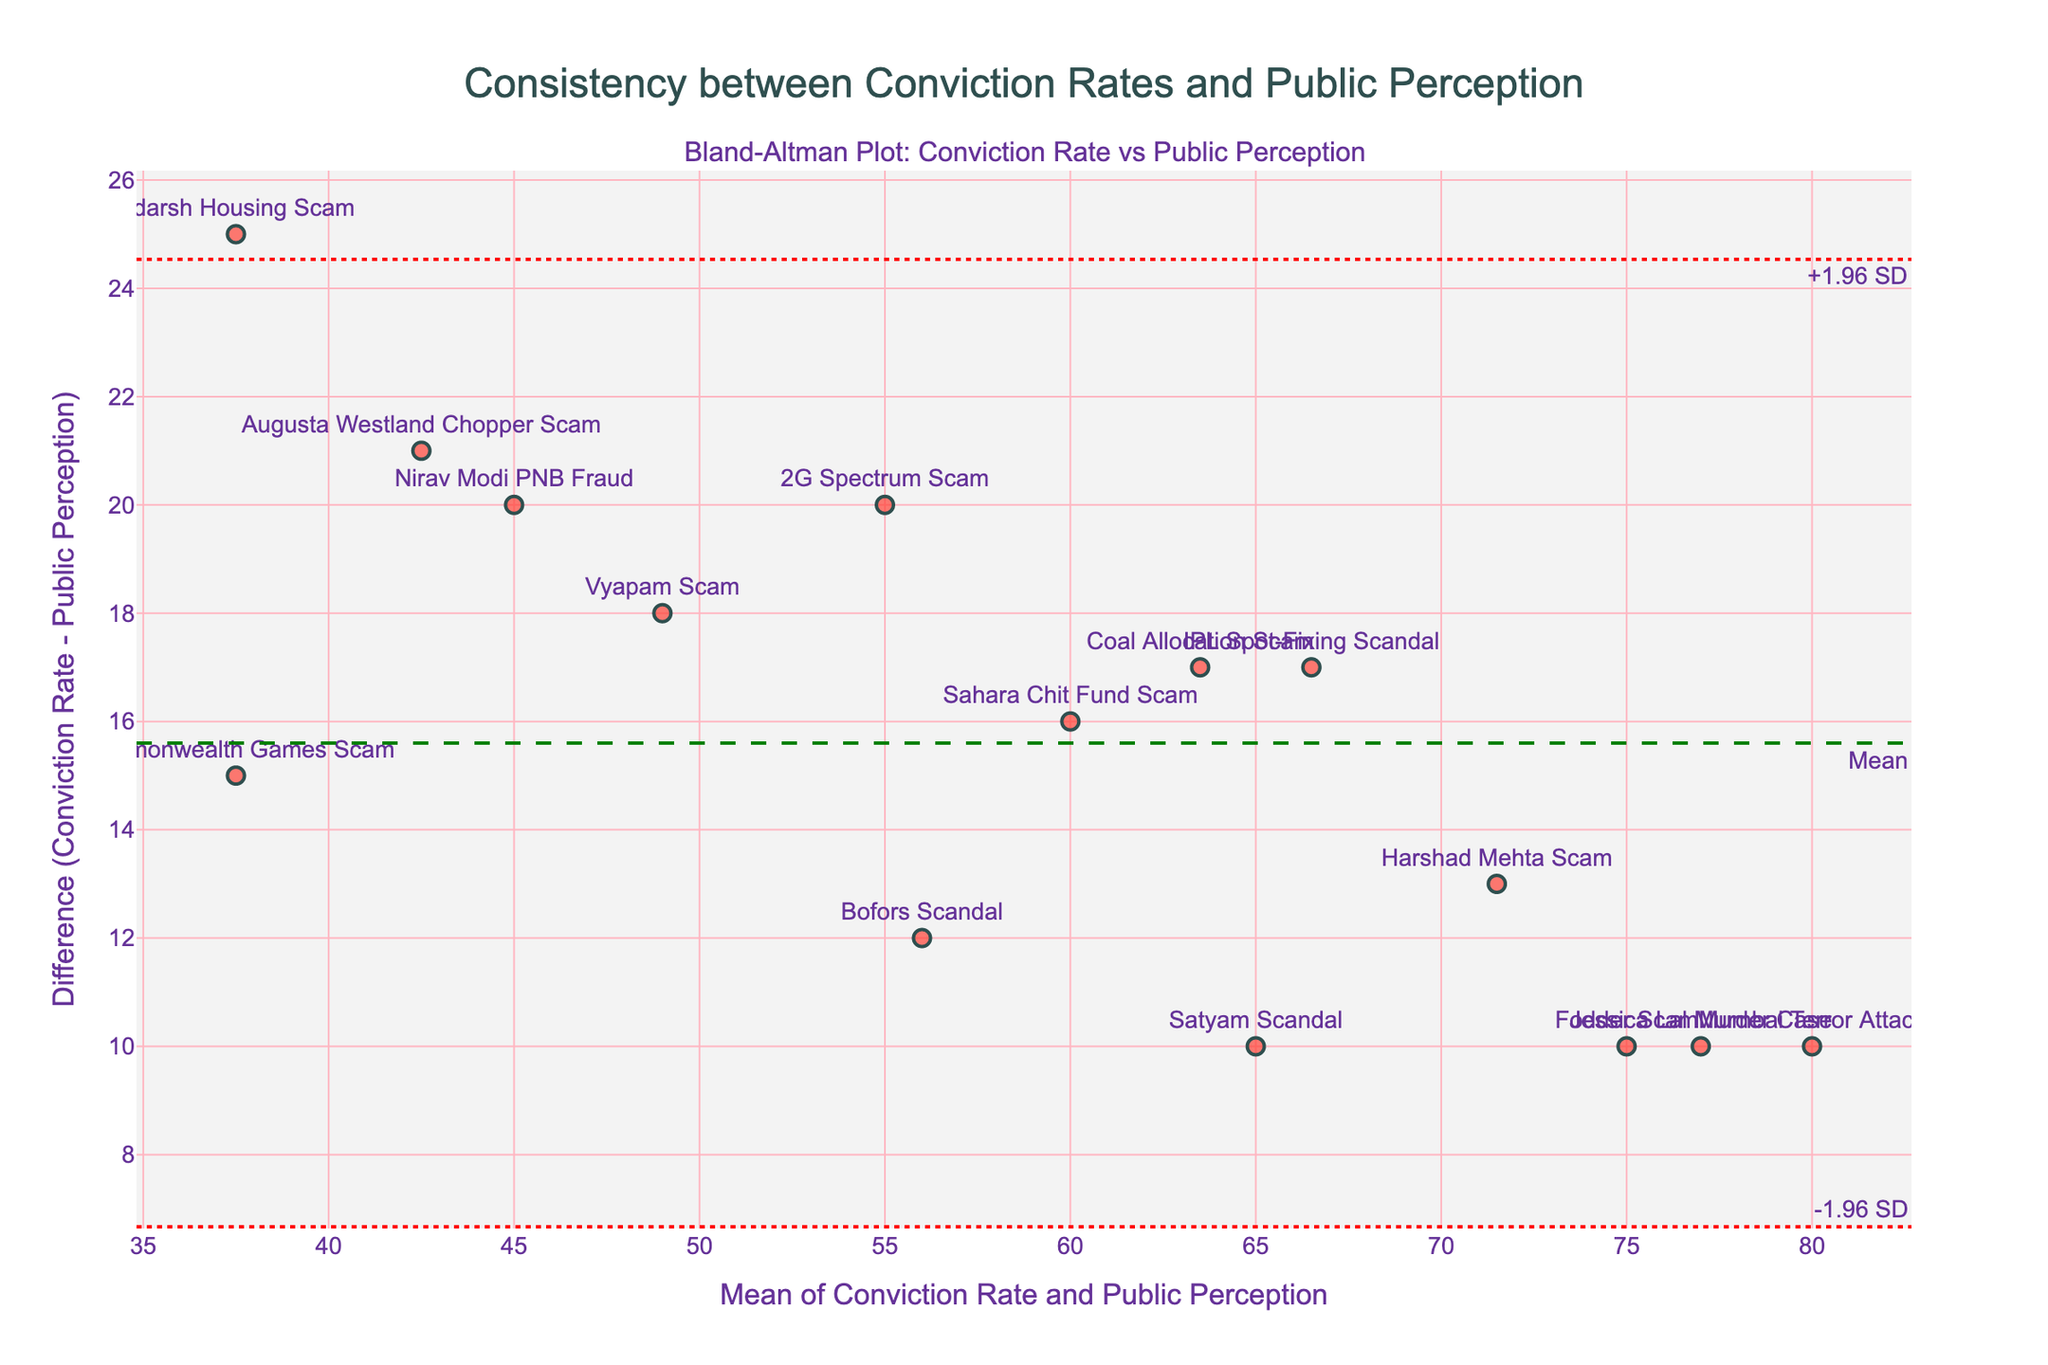What does the figure title indicate? The title of the figure is "Consistency between Conviction Rates and Public Perception," indicating that the plot aims to show how consistent the conviction rates are with the public's perception of justice being served.
Answer: Consistency between Conviction Rates and Public Perception What are the x-axis and y-axis labels? The x-axis is labeled "Mean of Conviction Rate and Public Perception," and the y-axis is labeled "Difference (Conviction Rate - Public Perception)."
Answer: Mean of Conviction Rate and Public Perception, Difference (Conviction Rate - Public Perception) How many cases are plotted in the figure? There are 15 cases plotted, as each point in the scatter plot represents one of the 15 different cases listed in the data provided.
Answer: 15 What does the horizontal green dashed line in the plot represent? The green dashed line represents the mean difference between the conviction rates and public perception.
Answer: Mean difference What do the red dotted lines represent in the figure? The red dotted lines represent the limits of agreement, which are ±1.96 standard deviations from the mean difference.
Answer: Limits of agreement Which case is closest to the mean line? The "Jessica Lal Murder Case" is closest to the mean line, as it has the smallest difference between the conviction rate and public perception.
Answer: Jessica Lal Murder Case What is the maximum difference observed and which case does it correspond to? The maximum difference observed is for the "Adarsh Housing Scam," with a difference of 25 (Conviction Rate 50 - Public Perception 25).
Answer: Adarsh Housing Scam What is the average mean value of the data points? To calculate the average mean value, sum up the mean values of all cases and then divide by the number of cases. The individual means are [(65+45)/2, (72+55)/2, ..., (82+72)/2]. The average mean is approximately 57.
Answer: 57 Which cases have a perception of justice that falls within the limits of agreement? By observing the scatter plot, cases within the red dotted lines (+1.96 SD and -1.96 SD) have perceptions of justice within the limits of agreement. Specific cases within these bounds include the "Nirav Modi PNB Fraud", "2G Spectrum Scam", and others.
Answer: Most cases within dotted red lines Are there any cases where the conviction rate significantly exceeds public perception? Yes, the "Adarsh Housing Scam" and the "Commonwealth Games Scam" show significant differences where the conviction rate is much higher than public perception.
Answer: Adarsh Housing Scam, Commonwealth Games Scam 